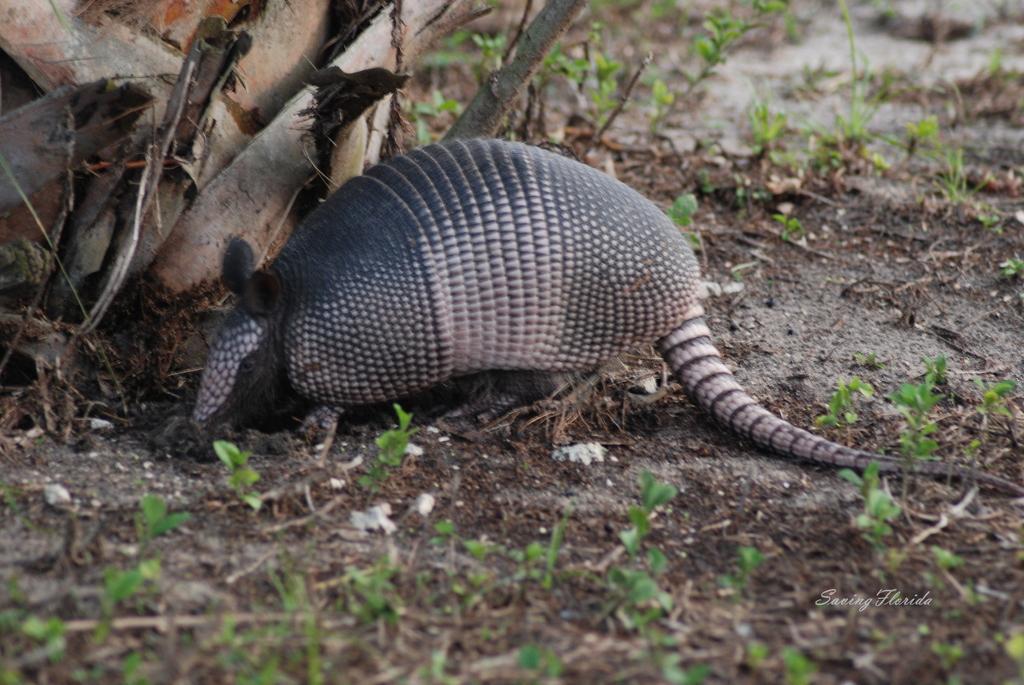Could you give a brief overview of what you see in this image? In the picture I can see an animal on the ground. I can also the grass and some other objects. 